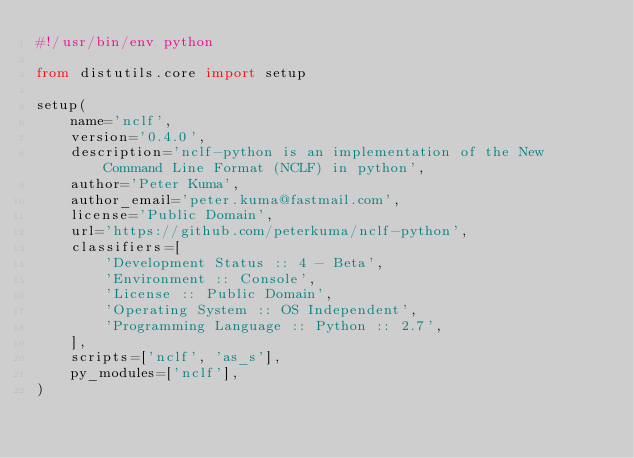<code> <loc_0><loc_0><loc_500><loc_500><_Python_>#!/usr/bin/env python

from distutils.core import setup

setup(
    name='nclf',
    version='0.4.0',
    description='nclf-python is an implementation of the New Command Line Format (NCLF) in python',
    author='Peter Kuma',
    author_email='peter.kuma@fastmail.com',
    license='Public Domain',
    url='https://github.com/peterkuma/nclf-python',
    classifiers=[
        'Development Status :: 4 - Beta',
        'Environment :: Console',
        'License :: Public Domain',
        'Operating System :: OS Independent',
        'Programming Language :: Python :: 2.7',
    ],
    scripts=['nclf', 'as_s'],
    py_modules=['nclf'],
)
</code> 